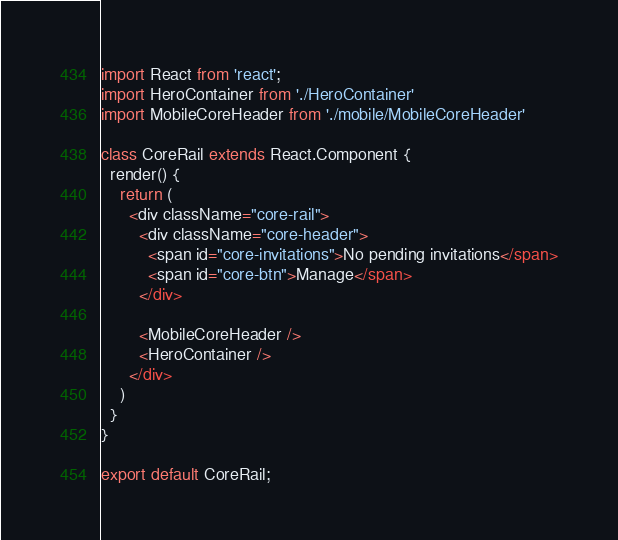<code> <loc_0><loc_0><loc_500><loc_500><_JavaScript_>import React from 'react';
import HeroContainer from './HeroContainer'
import MobileCoreHeader from './mobile/MobileCoreHeader'

class CoreRail extends React.Component {
  render() {
    return (
      <div className="core-rail">
        <div className="core-header">
          <span id="core-invitations">No pending invitations</span>
          <span id="core-btn">Manage</span>
        </div>

        <MobileCoreHeader />
        <HeroContainer />
      </div>
    )
  }
}

export default CoreRail;
</code> 